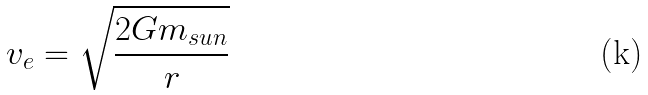<formula> <loc_0><loc_0><loc_500><loc_500>v _ { e } = \sqrt { \frac { 2 G m _ { s u n } } { r } }</formula> 